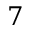Convert formula to latex. <formula><loc_0><loc_0><loc_500><loc_500>7</formula> 